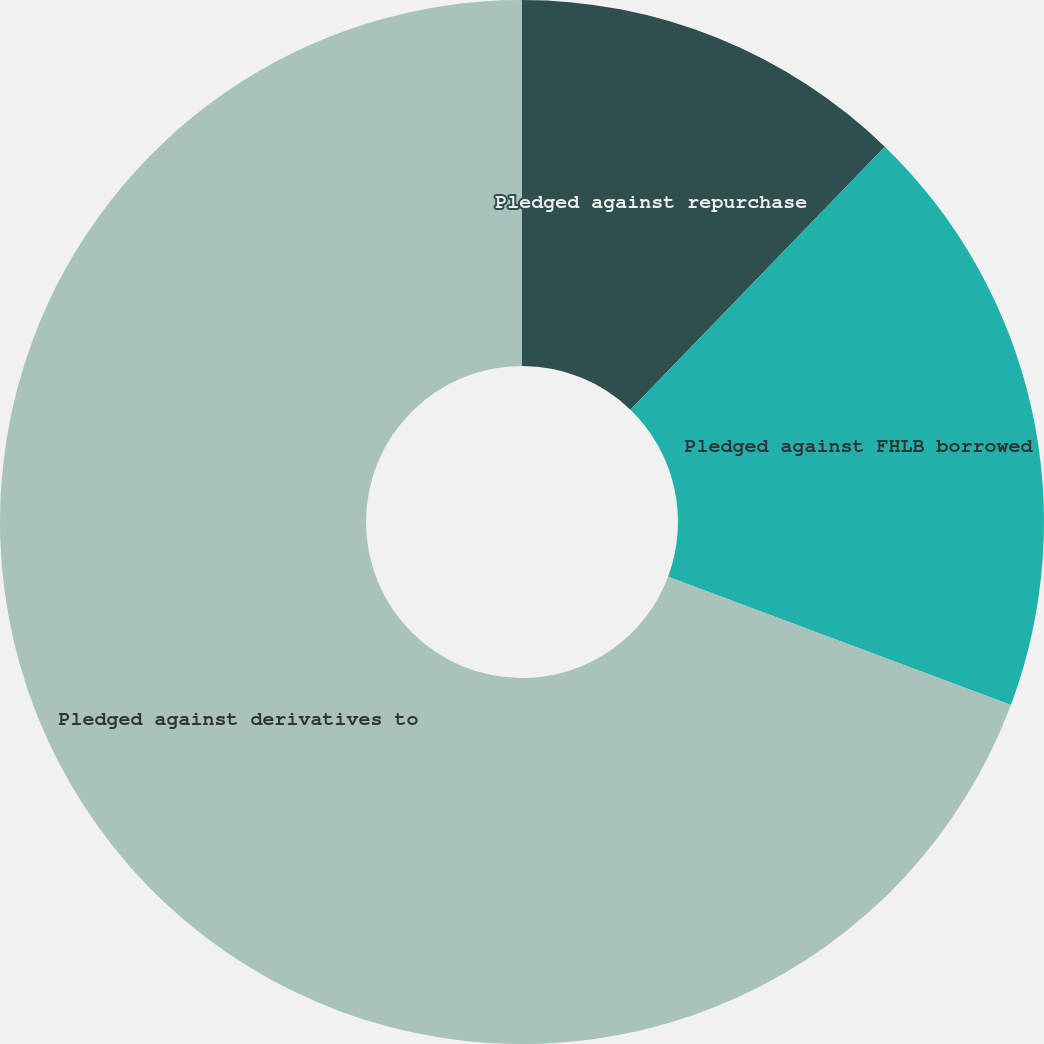Convert chart. <chart><loc_0><loc_0><loc_500><loc_500><pie_chart><fcel>Pledged against repurchase<fcel>Pledged against FHLB borrowed<fcel>Pledged against derivatives to<nl><fcel>12.23%<fcel>18.47%<fcel>69.3%<nl></chart> 